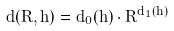<formula> <loc_0><loc_0><loc_500><loc_500>d ( R , h ) = d _ { 0 } ( h ) \cdot R ^ { d _ { 1 } ( h ) }</formula> 